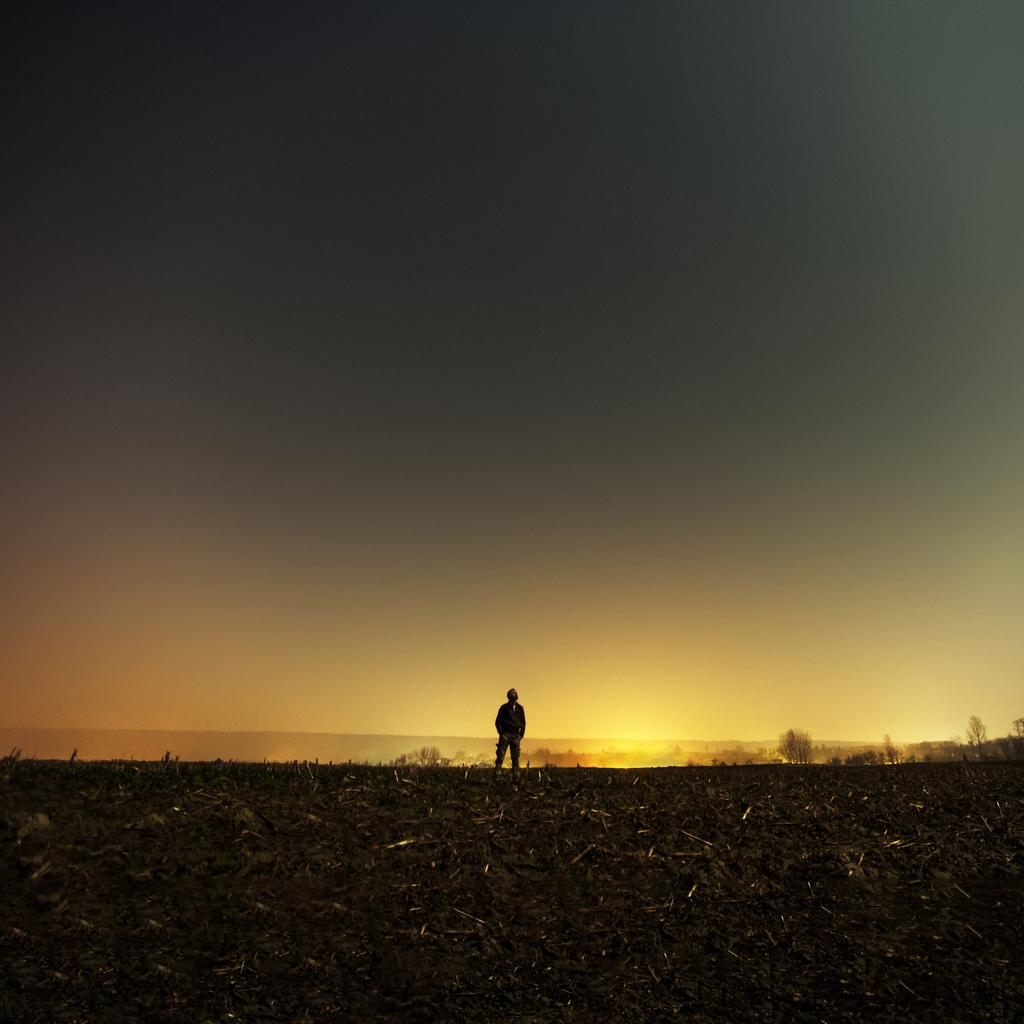What is the main subject in the foreground of the image? There is a man standing in the foreground of the image. What is the man standing on? The man is standing on the ground. What colors can be seen in the background of the image? There are golden and orange color lights in the background of the image. What is visible at the top of the image? The sky is visible at the top of the image. What type of crime is the man committing in the image? There is no indication of a crime being committed in the image; the man is simply standing on the ground. How does the man feel about the mark on his forehead in the image? There is no mark on the man's forehead in the image, and therefore no indication of how he might feel about it. 